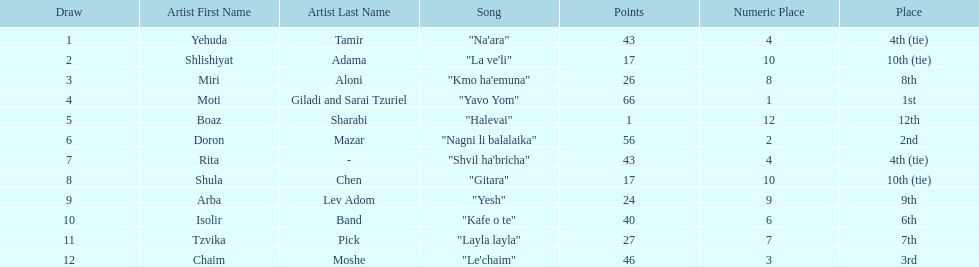What song earned the most points? "Yavo Yom". 